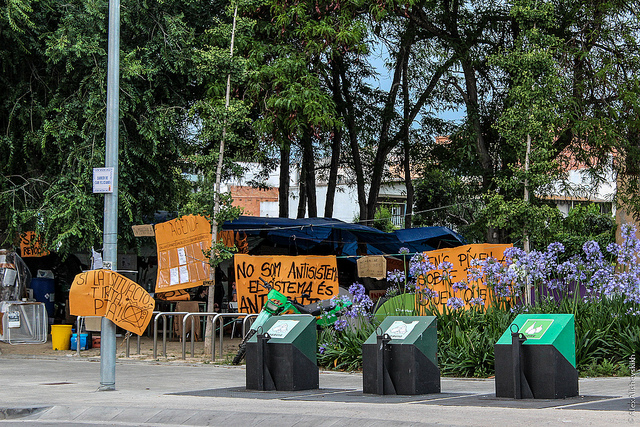<image>What mode of transportation can be seen? There is no transportation mode can be seen in the image. But it might be a bike, motor scooter, motorcycle or bus. What mode of transportation can be seen? I am not sure. It can be seen 'bike', 'motor scooter', 'motorcycle' or 'bus'. 